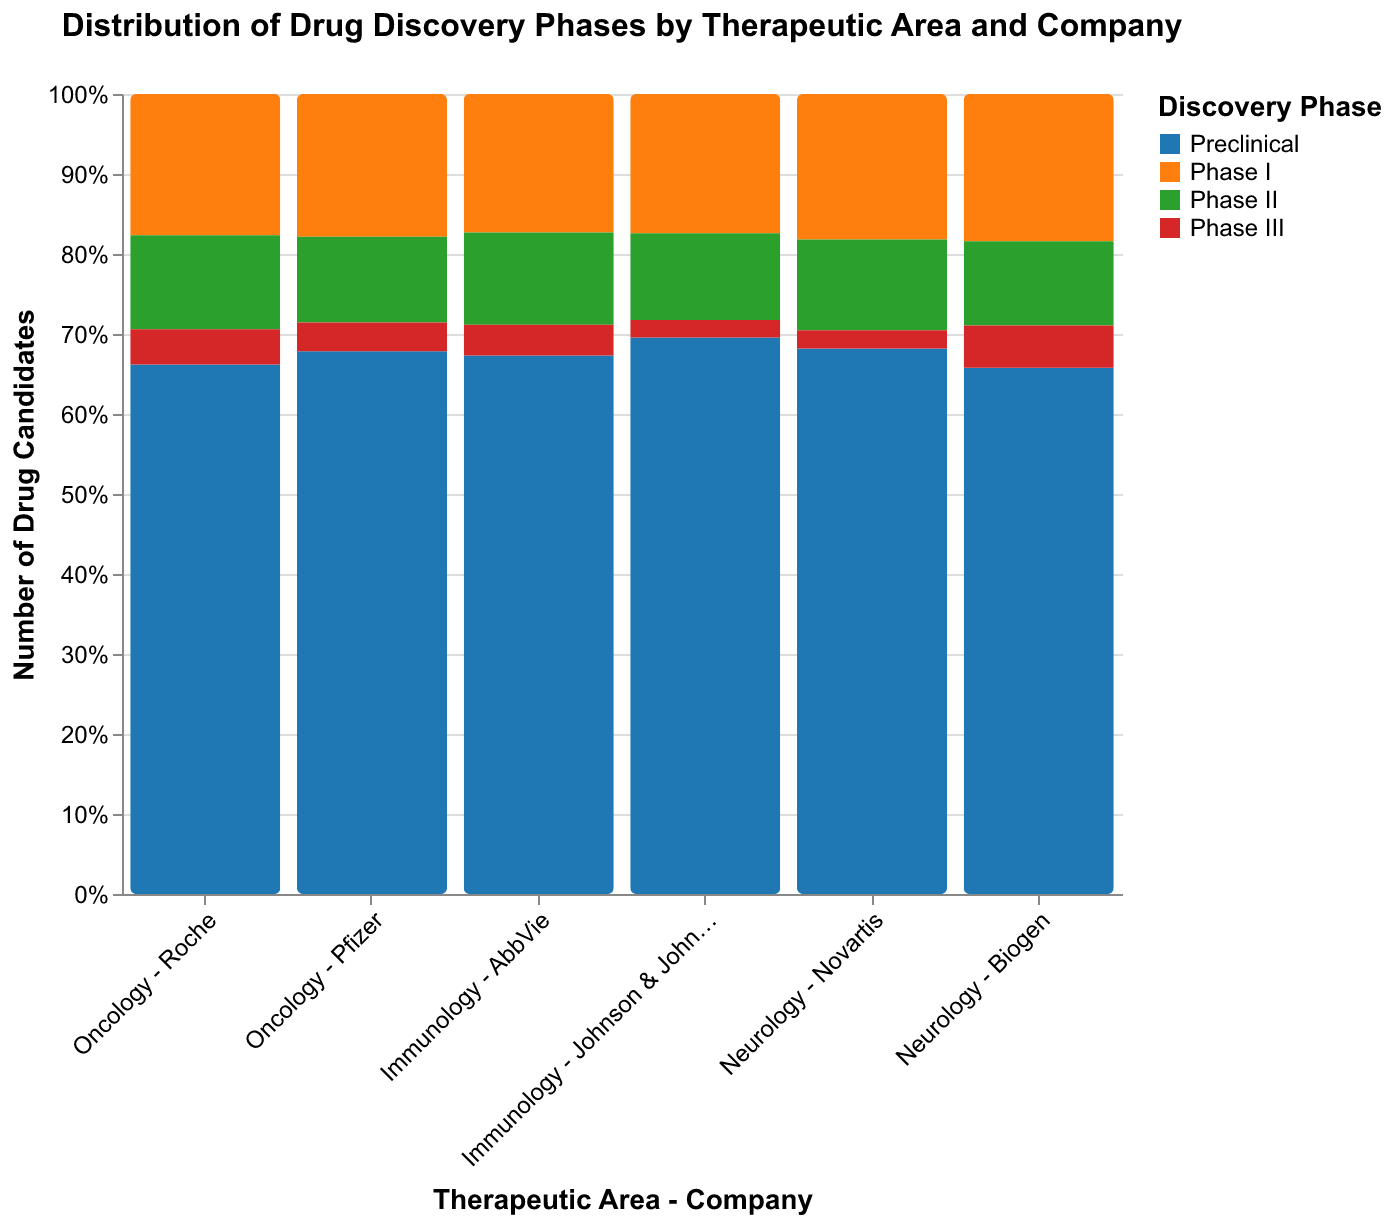What is the title of the chart? The title of the chart is positioned at the top center of the figure.
Answer: Distribution of Drug Discovery Phases by Therapeutic Area and Company Which company has the highest number of Preclinical drug candidates in Oncology? For Oncology, compare the heights of the blue bars (Preclinical phase) for Roche and Pfizer. The taller bar indicates a higher count. Roche's bar is taller.
Answer: Roche How many companies are represented in the Neurology therapeutic area? Look at the x-axis labels for Neurology. The labels 'Novartis' and 'Biogen' appear under Neurology. Summing them up gives the total number of companies.
Answer: 2 Which discovery phase is represented with red color? From the legend, identify the color red and find the corresponding discovery phase.
Answer: Phase III Which therapeutic area has the most uniform distribution of drug discovery phases? Observe the stacked bar heights for all phases within each therapeutic area. The area where bars (colors) are most evenly distributed across phases indicates uniformity. Immunology appears more uniform compared to others.
Answer: Immunology Which company has the minimum number of drug candidates in Phase II for Immunology? Compare the heights of the green bars (Phase II) under Immunology for AbbVie and Johnson & Johnson. The shorter bar indicates the minimum count. Johnson & Johnson's bar is shorter.
Answer: Johnson & Johnson What is the total number of Preclinical drug candidates in Oncology? Add the counts of the Preclinical candidates from Roche and Pfizer in Oncology (45 + 38).
Answer: 83 Which company has a higher total number of drug candidates in Neurology, Novartis or Biogen? Sum up the counts of all discovery phases for both Novartis and Biogen in Neurology. Novartis: 30 + 8 + 5 + 1 = 44, Biogen: 25 + 7 + 4 + 2 = 38. Compare the totals.
Answer: Novartis Compare the number of Phase I drug candidates between Roche and Pfizer in Oncology. Which one has more? Check the heights of the corresponding orange bars (Phase I) for Roche and Pfizer in Oncology. Roche: 12, Pfizer: 10. Roche has more.
Answer: Roche How many companies have drug candidates in Phase III in Immunology? Check the presence of red bars (Phase III) under Immunology. Both AbbVie and Johnson & Johnson have Phase III candidates.
Answer: 2 